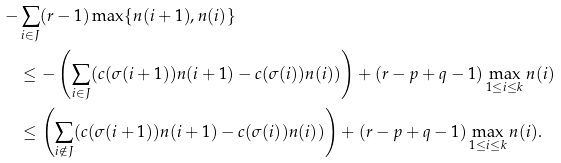<formula> <loc_0><loc_0><loc_500><loc_500>- & \sum _ { i \in J } ( r - 1 ) \max \{ n ( i + 1 ) , n ( i ) \} \\ & \leq - \left ( \sum _ { i \in J } ( c ( \sigma ( i + 1 ) ) n ( i + 1 ) - c ( \sigma ( i ) ) n ( i ) ) \right ) + ( r - p + q - 1 ) \max _ { 1 \leq i \leq k } n ( i ) \\ & \leq \left ( \sum _ { i \notin J } ( c ( \sigma ( i + 1 ) ) n ( i + 1 ) - c ( \sigma ( i ) ) n ( i ) ) \right ) + ( r - p + q - 1 ) \max _ { 1 \leq i \leq k } n ( i ) .</formula> 